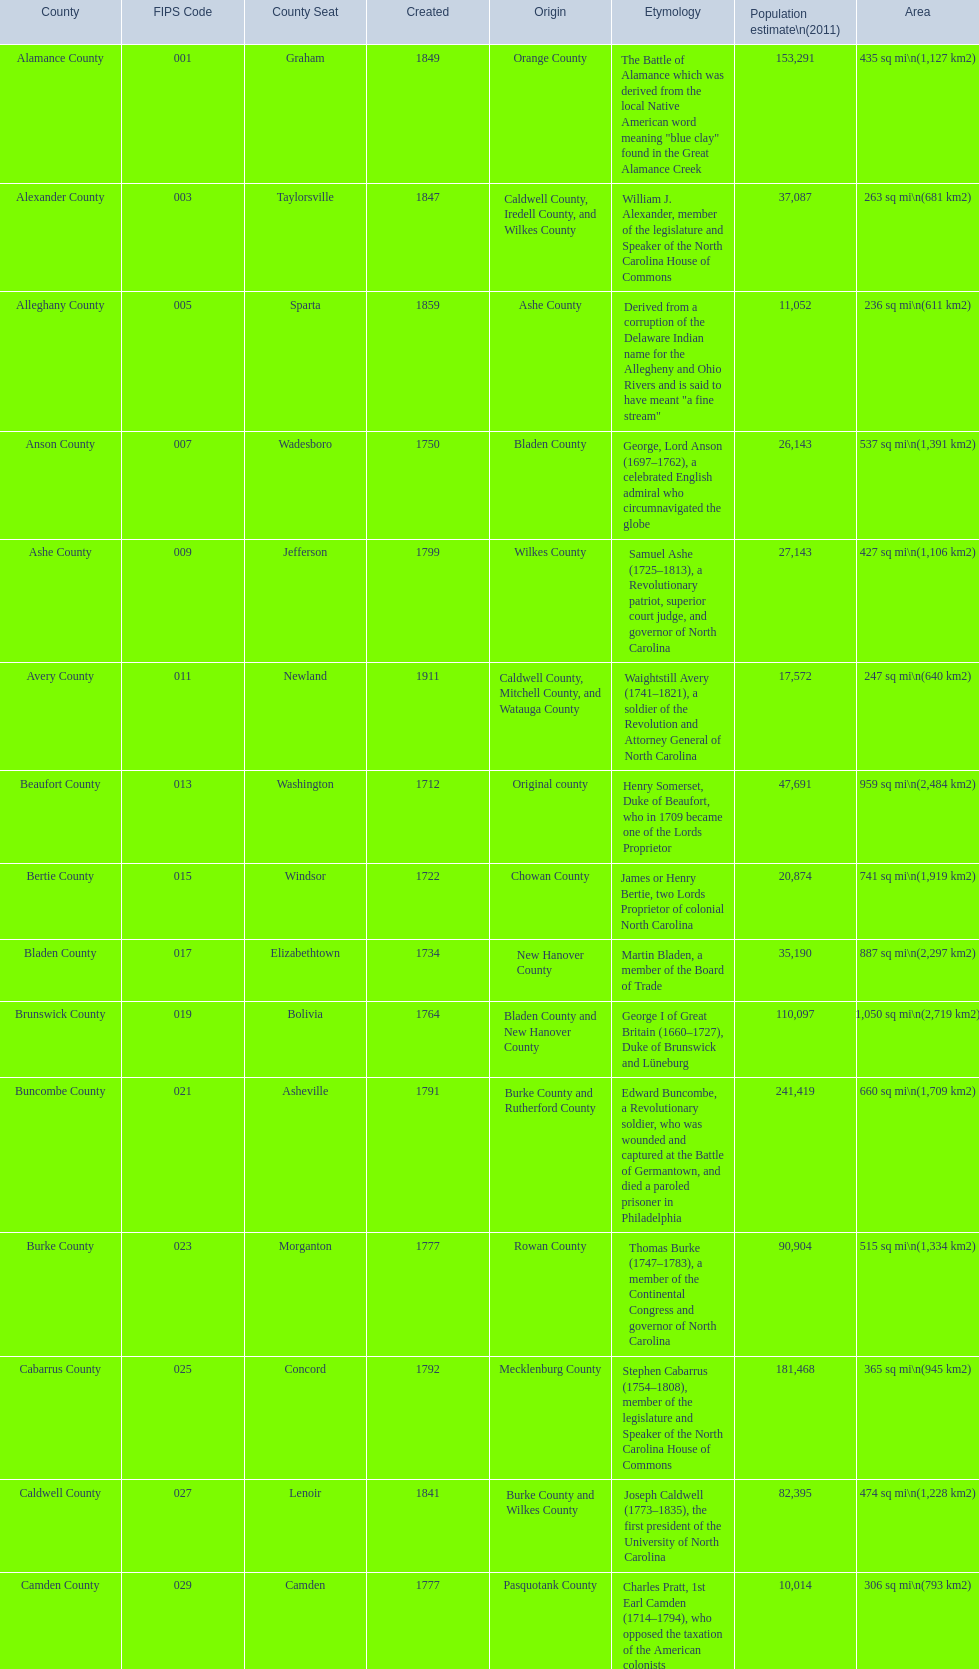Which county encompasses the largest area? Dare County. 